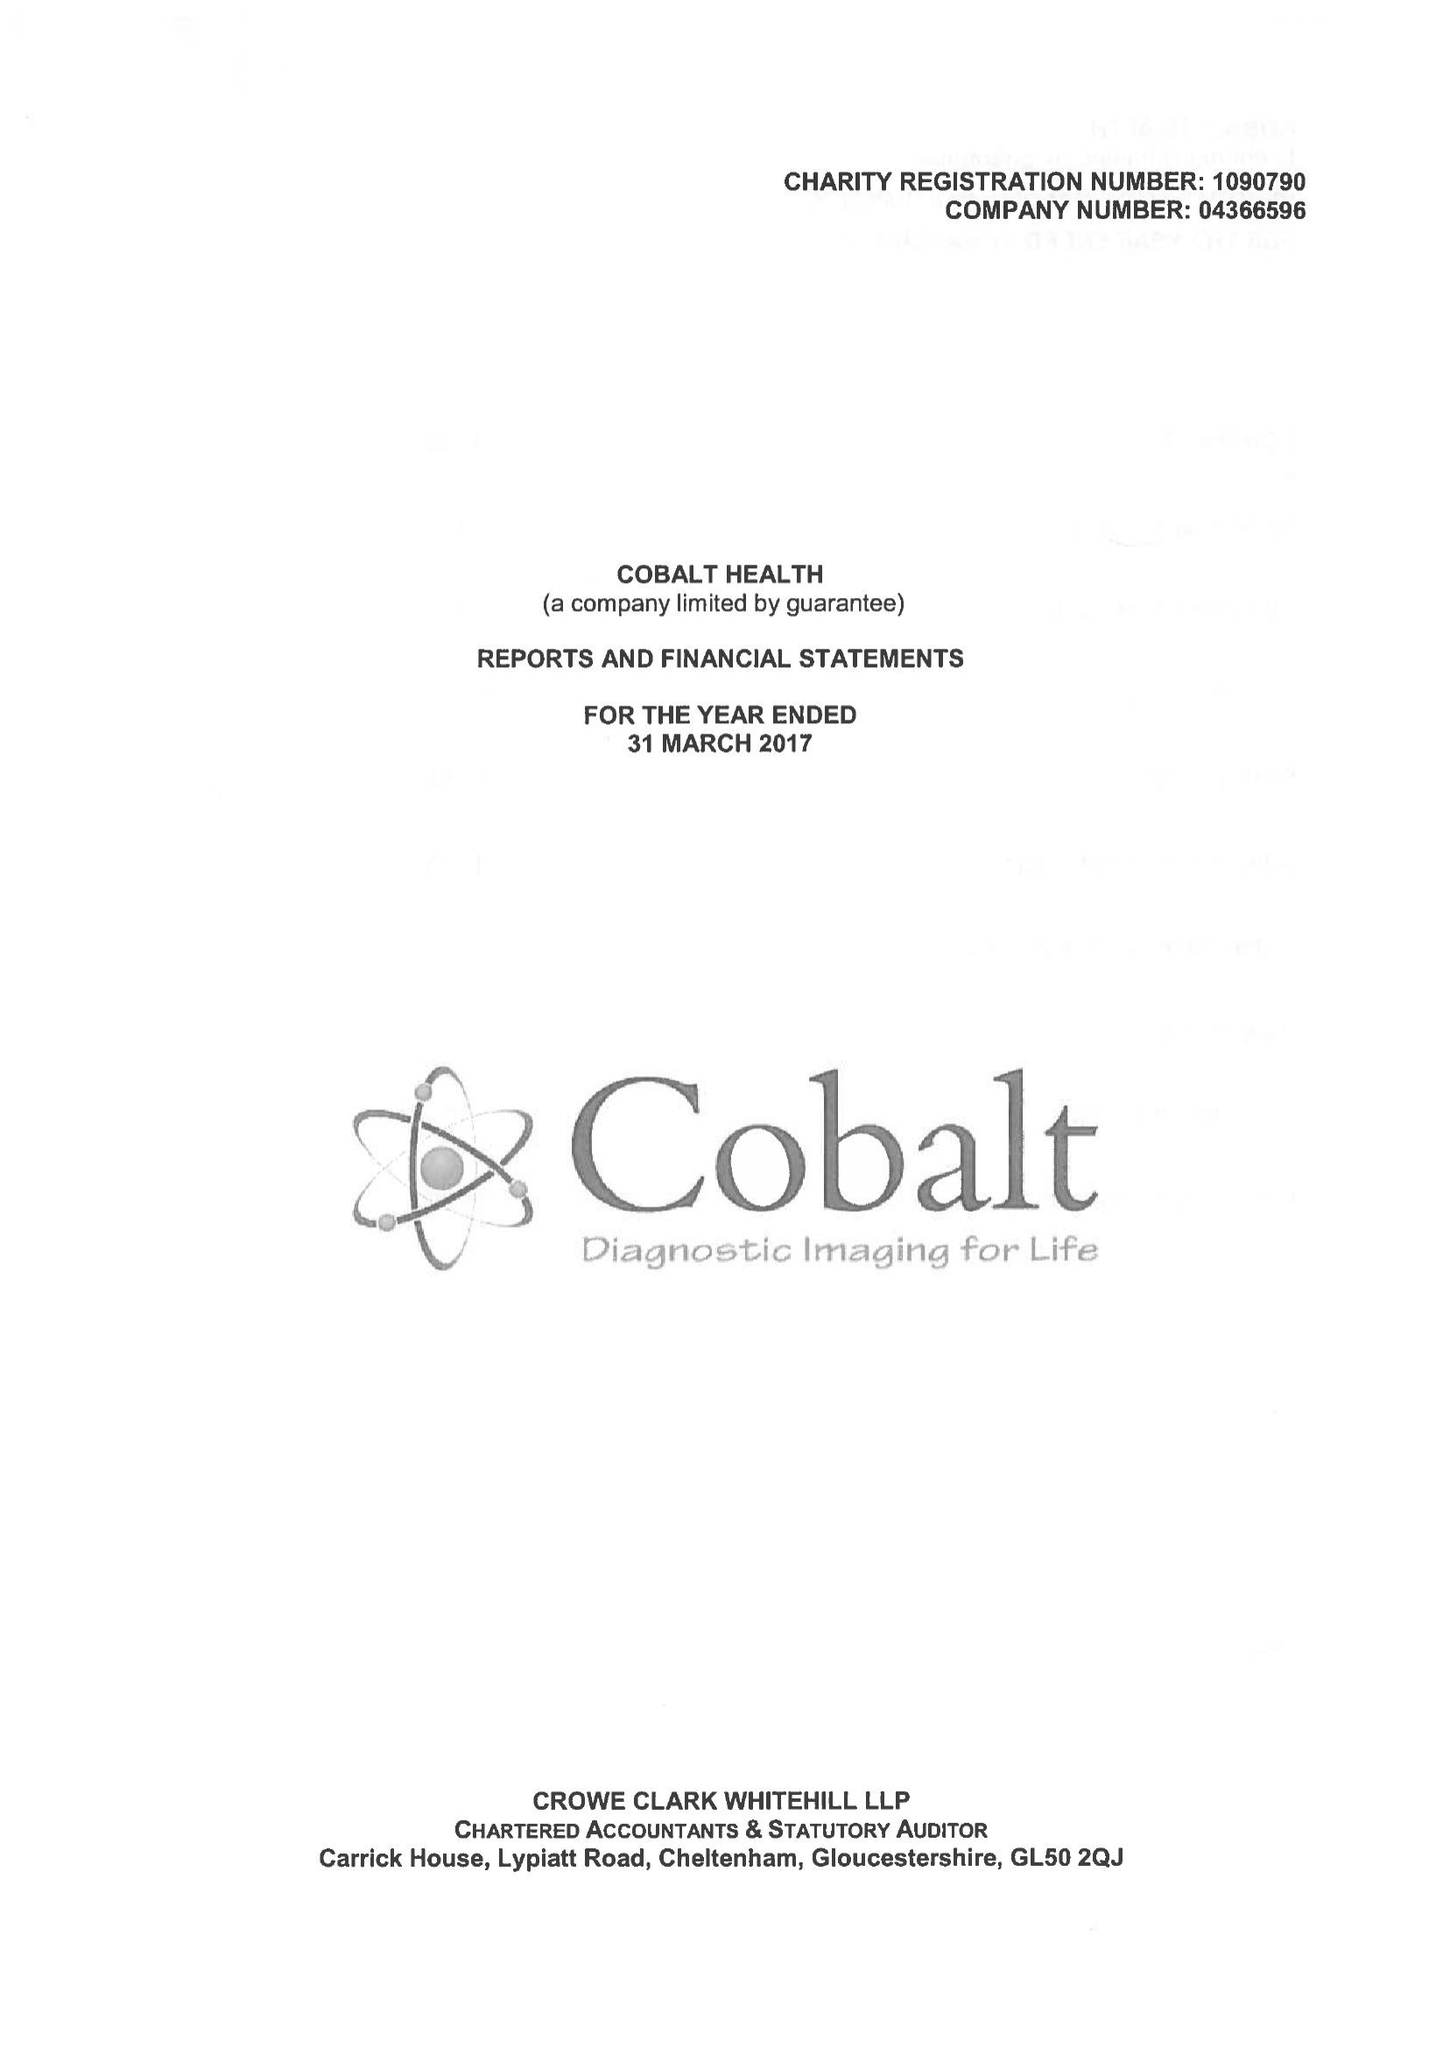What is the value for the address__post_town?
Answer the question using a single word or phrase. CHELTENHAM 